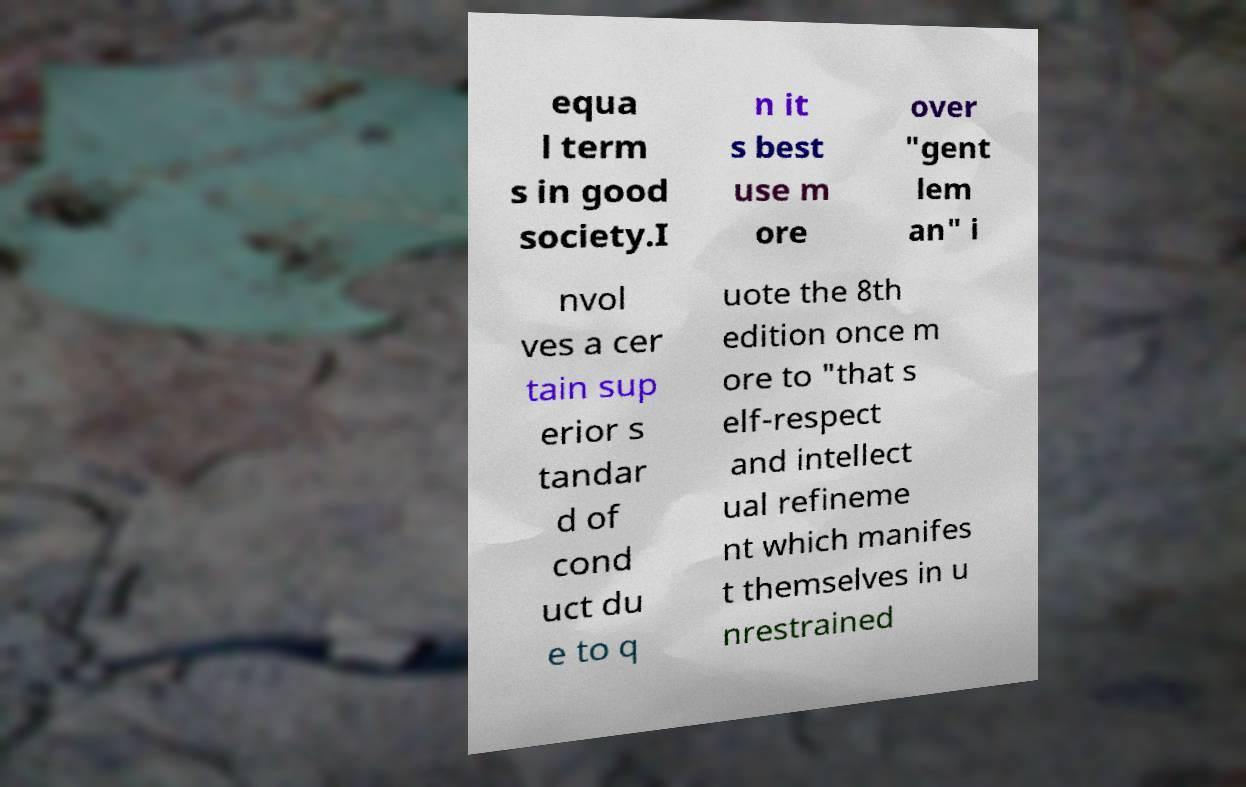Please identify and transcribe the text found in this image. equa l term s in good society.I n it s best use m ore over "gent lem an" i nvol ves a cer tain sup erior s tandar d of cond uct du e to q uote the 8th edition once m ore to "that s elf-respect and intellect ual refineme nt which manifes t themselves in u nrestrained 